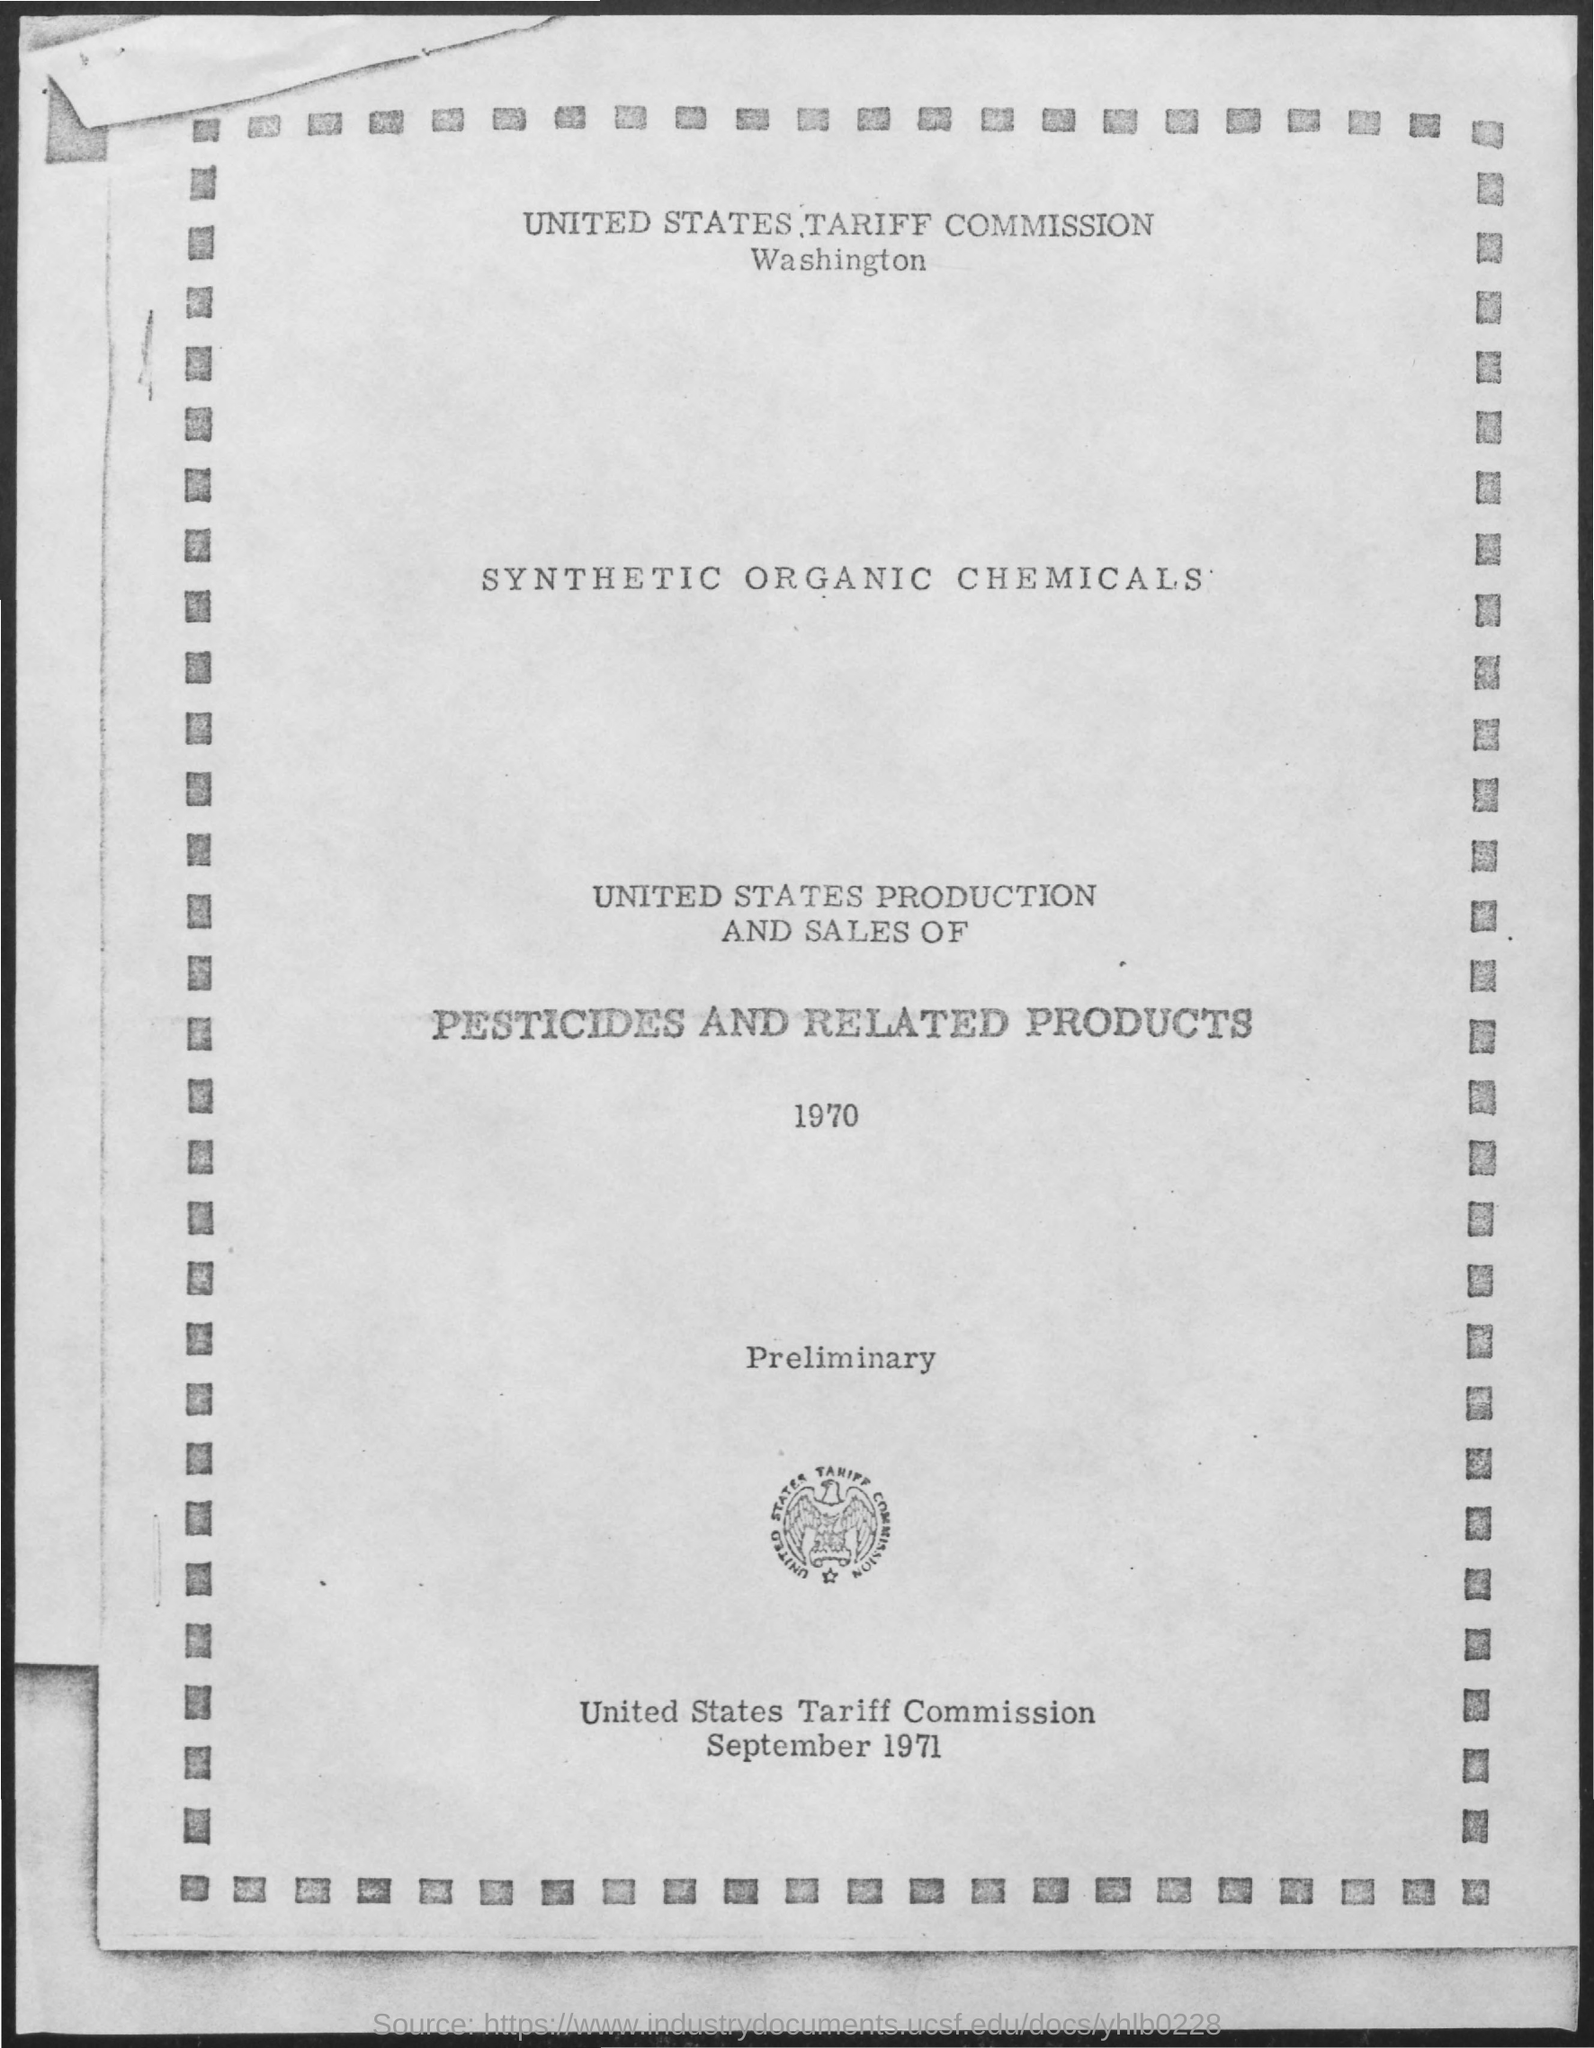List a handful of essential elements in this visual. The United States Tariff Commission is the name of a commission. The date mentioned is September 1971. 